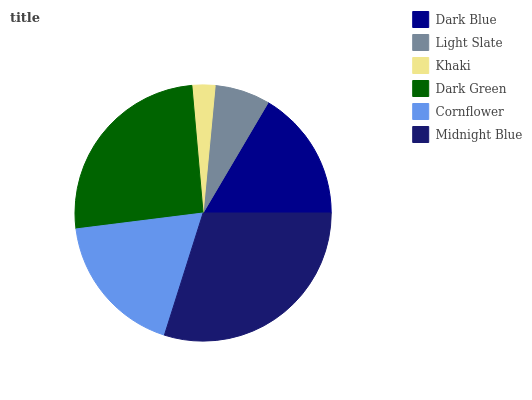Is Khaki the minimum?
Answer yes or no. Yes. Is Midnight Blue the maximum?
Answer yes or no. Yes. Is Light Slate the minimum?
Answer yes or no. No. Is Light Slate the maximum?
Answer yes or no. No. Is Dark Blue greater than Light Slate?
Answer yes or no. Yes. Is Light Slate less than Dark Blue?
Answer yes or no. Yes. Is Light Slate greater than Dark Blue?
Answer yes or no. No. Is Dark Blue less than Light Slate?
Answer yes or no. No. Is Cornflower the high median?
Answer yes or no. Yes. Is Dark Blue the low median?
Answer yes or no. Yes. Is Dark Blue the high median?
Answer yes or no. No. Is Midnight Blue the low median?
Answer yes or no. No. 